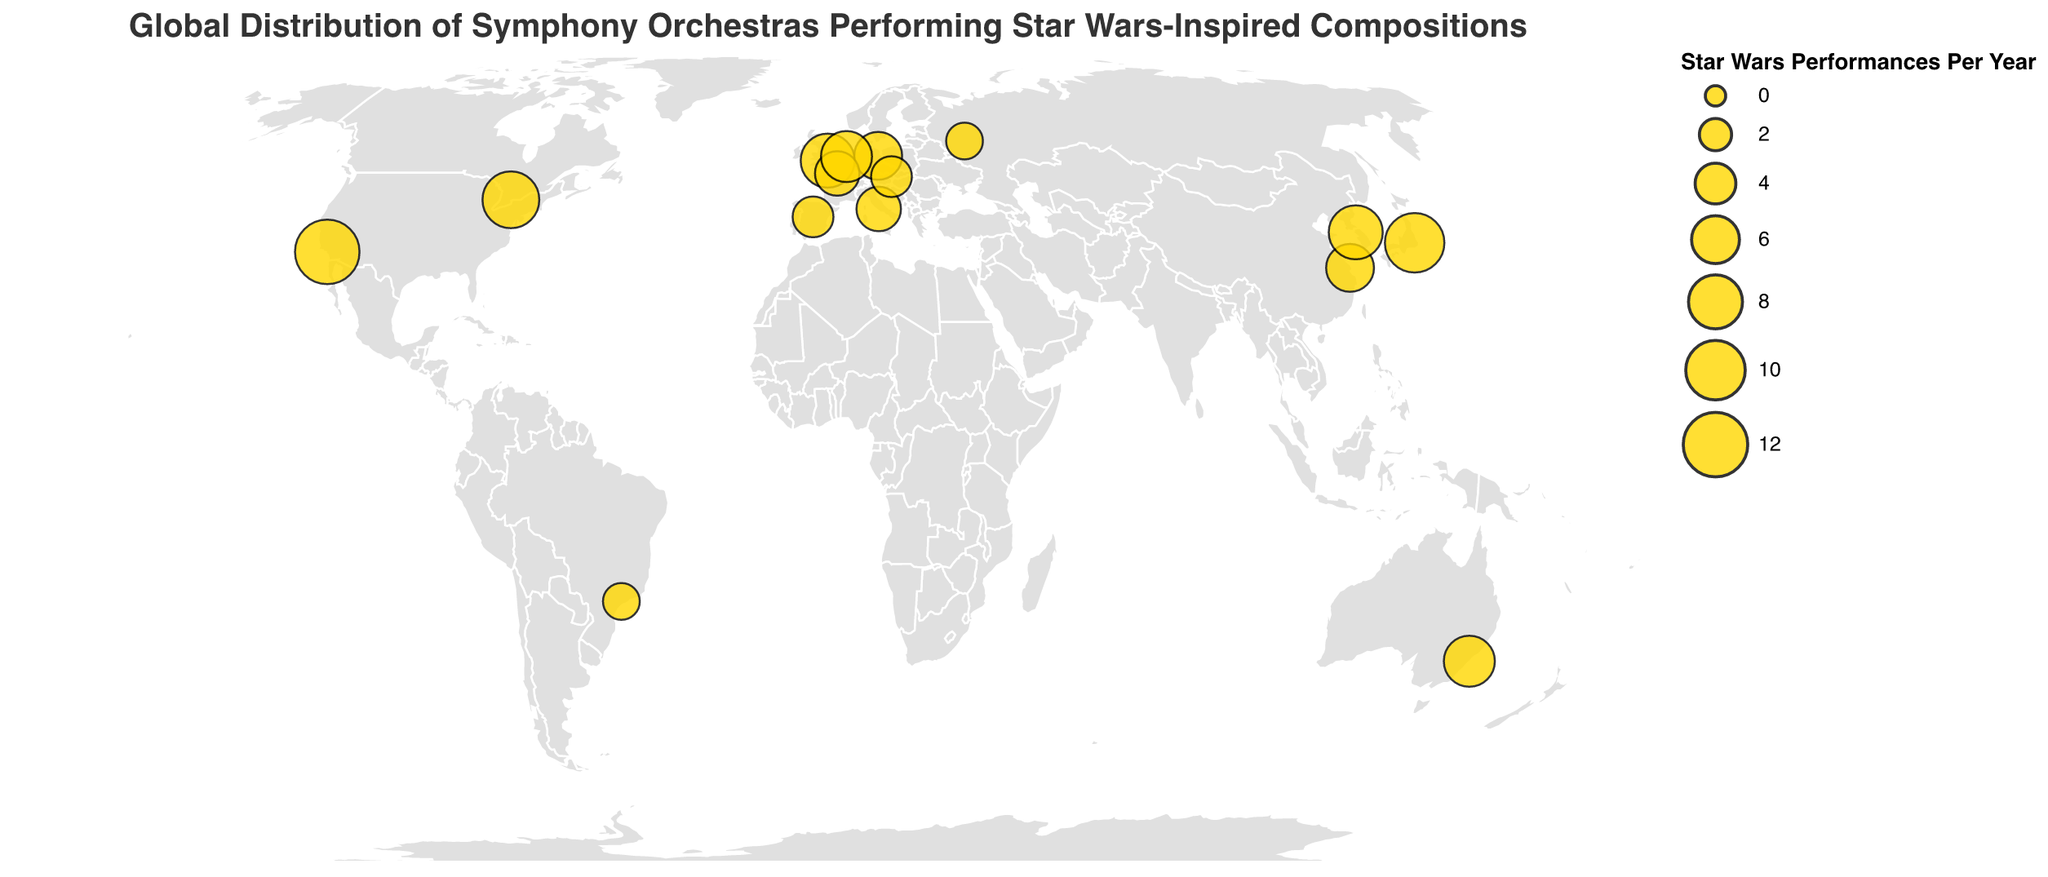What's the title of the figure? The title is usually displayed at the top of the figure, providing an overview of what the plot represents. In this case, the title is "Global Distribution of Symphony Orchestras Performing Star Wars-Inspired Compositions."
Answer: Global Distribution of Symphony Orchestras Performing Star Wars-Inspired Compositions Which orchestra performs the most Star Wars-inspired compositions per year? To determine this, look for the largest circle on the map. According to the tooltip, the Los Angeles Philharmonic in the USA performs 12 Star Wars-inspired compositions per year, which is the highest.
Answer: Los Angeles Philharmonic How many orchestras perform at least 8 Star Wars-inspired compositions per year? Identify all circles representing orchestras that perform 8 or more compositions. According to the data, these are in Los Angeles, Tokyo, Seoul, London, and Toronto. There are 5 such orchestras.
Answer: 5 What is the total number of Star Wars-inspired performances per year by the orchestras in Europe? Sum the number of performances by orchestras located in Europe: London (8), Berlin (6), Paris (5), Madrid (4), Rome (5), Amsterdam (7), Vienna (4). The total is 39.
Answer: 39 Which city has the smallest number of Star Wars-inspired performances per year, and how many? Locate the smallest circles on the map and check the tooltips. Moscow and São Paulo each have 3 performances per year, which is the smallest number.
Answer: Moscow and São Paulo, 3 Compare the number of Star Wars-inspired performances per year between the Tokyo Philharmonic Orchestra and the Berlin Philharmonic. Check the values for both orchestras. Tokyo Philharmonic Orchestra has 10, and Berlin Philharmonic has 6. Tokyo performs 4 more compositions than Berlin per year.
Answer: Tokyo performs 4 more than Berlin Which continents have the orchestras that perform Star Wars-inspired compositions? Analyze the geographic locations of the orchestras. They are in North America, South America, Europe, Asia, and Australia.
Answer: North America, South America, Europe, Asia, Australia What is the average number of Star Wars-inspired performances per year by orchestras listed? To get the average, sum up the total performances and divide by the number of orchestras: (12 + 8 + 6 + 10 + 7 + 9 + 5 + 4 + 3 + 6 + 5 + 7 + 4 + 3 + 8) / 15 = 7.
Answer: 7 From a geographic perspective, which region has the highest density of orchestras performing Star Wars-inspired compositions? Examine the spread of orchestras on the map. Europe shows the highest density with multiple orchestras in close proximity: London, Berlin, Paris, Madrid, Rome, Amsterdam, and Vienna.
Answer: Europe How does the number of Star Wars-inspired performances by the Sydney Symphony Orchestra compare to that by the Royal Concertgebouw Orchestra? Sydney Symphony Orchestra has 7 performances, and Royal Concertgebouw Orchestra also has 7 performances per year. They perform the same number of compositions.
Answer: Equal 